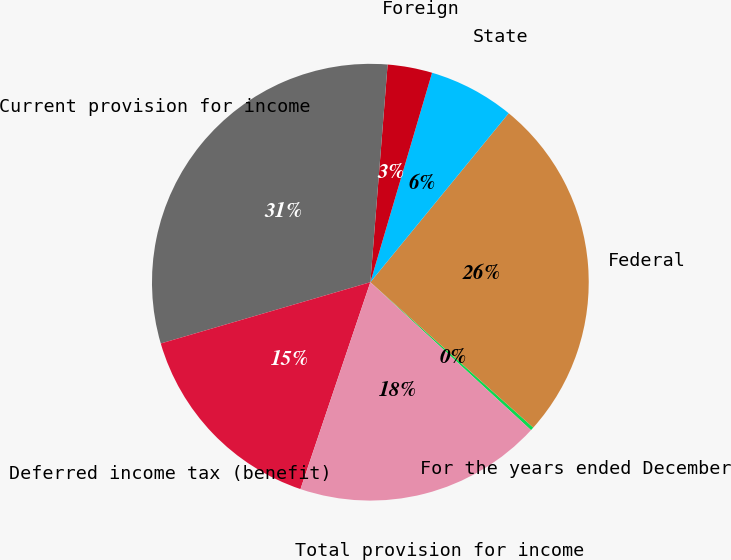<chart> <loc_0><loc_0><loc_500><loc_500><pie_chart><fcel>For the years ended December<fcel>Federal<fcel>State<fcel>Foreign<fcel>Current provision for income<fcel>Deferred income tax (benefit)<fcel>Total provision for income<nl><fcel>0.25%<fcel>25.68%<fcel>6.36%<fcel>3.3%<fcel>30.79%<fcel>15.29%<fcel>18.34%<nl></chart> 